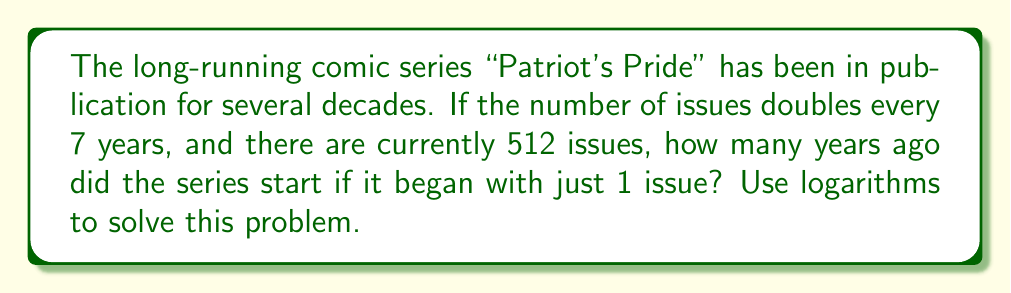Help me with this question. Let's approach this step-by-step using logarithms:

1) Let $x$ be the number of years since the series started.

2) We know that the number of issues doubles every 7 years. This can be expressed as:

   $$ 1 \cdot 2^{\frac{x}{7}} = 512 $$

3) Now, let's apply logarithms (base 2) to both sides:

   $$ \log_2(1 \cdot 2^{\frac{x}{7}}) = \log_2(512) $$

4) Using the logarithm property $\log_a(x^n) = n\log_a(x)$, we get:

   $$ \frac{x}{7} \cdot \log_2(2) = \log_2(512) $$

5) Since $\log_2(2) = 1$, this simplifies to:

   $$ \frac{x}{7} = \log_2(512) $$

6) We know that $512 = 2^9$, so:

   $$ \frac{x}{7} = 9 $$

7) Multiply both sides by 7:

   $$ x = 9 \cdot 7 = 63 $$

Therefore, the series started 63 years ago.
Answer: 63 years 